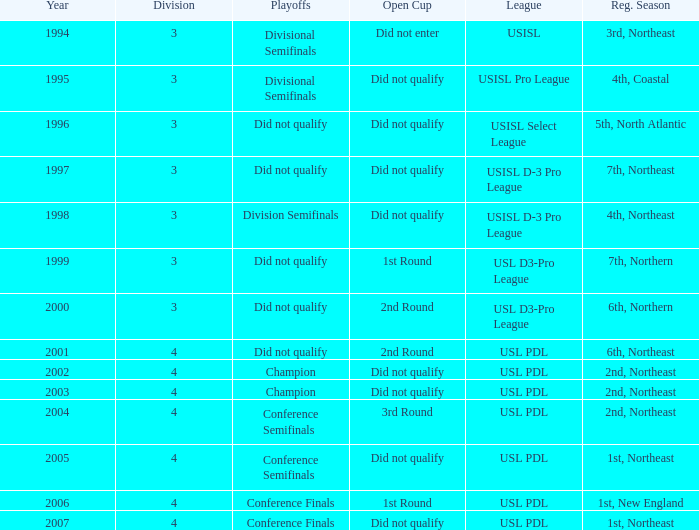Name the total number of years for usisl pro league 1.0. Would you be able to parse every entry in this table? {'header': ['Year', 'Division', 'Playoffs', 'Open Cup', 'League', 'Reg. Season'], 'rows': [['1994', '3', 'Divisional Semifinals', 'Did not enter', 'USISL', '3rd, Northeast'], ['1995', '3', 'Divisional Semifinals', 'Did not qualify', 'USISL Pro League', '4th, Coastal'], ['1996', '3', 'Did not qualify', 'Did not qualify', 'USISL Select League', '5th, North Atlantic'], ['1997', '3', 'Did not qualify', 'Did not qualify', 'USISL D-3 Pro League', '7th, Northeast'], ['1998', '3', 'Division Semifinals', 'Did not qualify', 'USISL D-3 Pro League', '4th, Northeast'], ['1999', '3', 'Did not qualify', '1st Round', 'USL D3-Pro League', '7th, Northern'], ['2000', '3', 'Did not qualify', '2nd Round', 'USL D3-Pro League', '6th, Northern'], ['2001', '4', 'Did not qualify', '2nd Round', 'USL PDL', '6th, Northeast'], ['2002', '4', 'Champion', 'Did not qualify', 'USL PDL', '2nd, Northeast'], ['2003', '4', 'Champion', 'Did not qualify', 'USL PDL', '2nd, Northeast'], ['2004', '4', 'Conference Semifinals', '3rd Round', 'USL PDL', '2nd, Northeast'], ['2005', '4', 'Conference Semifinals', 'Did not qualify', 'USL PDL', '1st, Northeast'], ['2006', '4', 'Conference Finals', '1st Round', 'USL PDL', '1st, New England'], ['2007', '4', 'Conference Finals', 'Did not qualify', 'USL PDL', '1st, Northeast']]} 